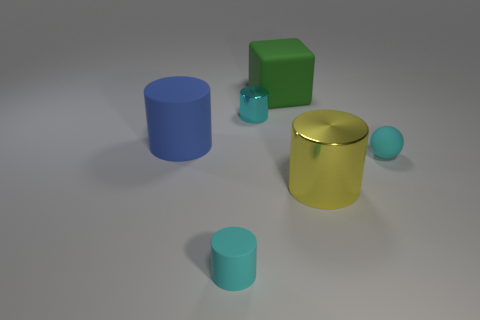Subtract all cyan blocks. How many cyan cylinders are left? 2 Subtract all blue cylinders. How many cylinders are left? 3 Subtract 2 cylinders. How many cylinders are left? 2 Subtract all red cylinders. Subtract all red spheres. How many cylinders are left? 4 Add 3 big blue objects. How many objects exist? 9 Subtract all cylinders. How many objects are left? 2 Subtract 0 brown spheres. How many objects are left? 6 Subtract all tiny blue matte cubes. Subtract all large metallic cylinders. How many objects are left? 5 Add 3 green matte blocks. How many green matte blocks are left? 4 Add 3 big yellow metallic cylinders. How many big yellow metallic cylinders exist? 4 